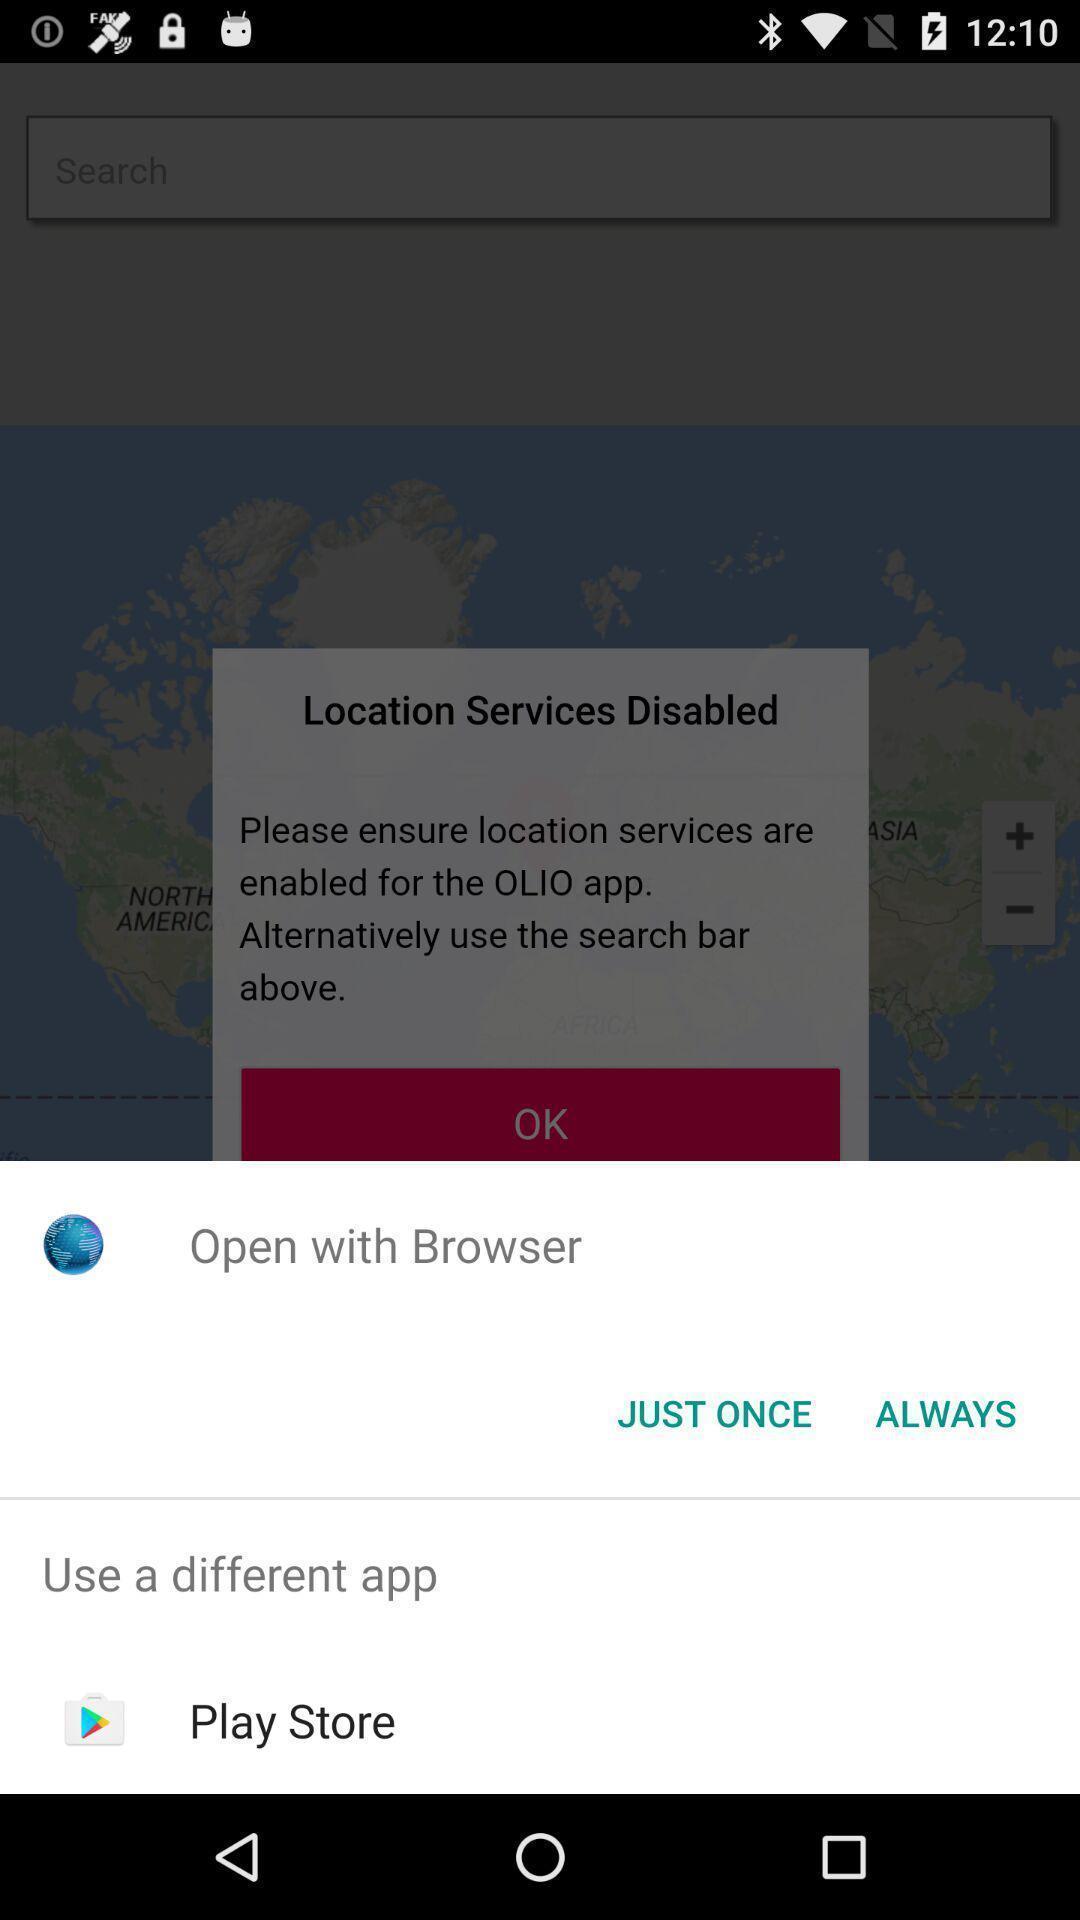Provide a description of this screenshot. Pop up showing to open the app. 